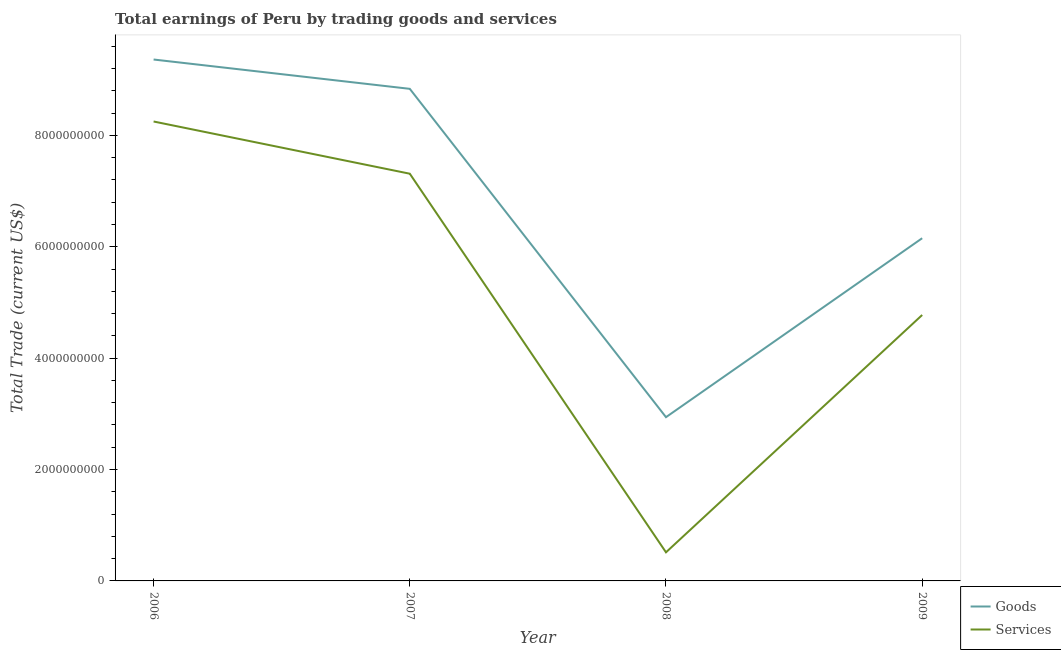How many different coloured lines are there?
Ensure brevity in your answer.  2. Is the number of lines equal to the number of legend labels?
Your answer should be very brief. Yes. What is the amount earned by trading goods in 2008?
Offer a very short reply. 2.94e+09. Across all years, what is the maximum amount earned by trading goods?
Offer a terse response. 9.36e+09. Across all years, what is the minimum amount earned by trading services?
Your answer should be compact. 5.14e+08. What is the total amount earned by trading services in the graph?
Keep it short and to the point. 2.08e+1. What is the difference between the amount earned by trading services in 2006 and that in 2007?
Keep it short and to the point. 9.37e+08. What is the difference between the amount earned by trading services in 2009 and the amount earned by trading goods in 2007?
Give a very brief answer. -4.06e+09. What is the average amount earned by trading goods per year?
Provide a succinct answer. 6.82e+09. In the year 2007, what is the difference between the amount earned by trading goods and amount earned by trading services?
Give a very brief answer. 1.52e+09. What is the ratio of the amount earned by trading goods in 2008 to that in 2009?
Offer a very short reply. 0.48. Is the difference between the amount earned by trading services in 2007 and 2009 greater than the difference between the amount earned by trading goods in 2007 and 2009?
Offer a very short reply. No. What is the difference between the highest and the second highest amount earned by trading services?
Your answer should be compact. 9.37e+08. What is the difference between the highest and the lowest amount earned by trading services?
Offer a very short reply. 7.74e+09. In how many years, is the amount earned by trading services greater than the average amount earned by trading services taken over all years?
Ensure brevity in your answer.  2. Is the sum of the amount earned by trading services in 2006 and 2007 greater than the maximum amount earned by trading goods across all years?
Keep it short and to the point. Yes. How many years are there in the graph?
Your answer should be compact. 4. What is the difference between two consecutive major ticks on the Y-axis?
Keep it short and to the point. 2.00e+09. Are the values on the major ticks of Y-axis written in scientific E-notation?
Provide a short and direct response. No. Does the graph contain grids?
Provide a short and direct response. No. What is the title of the graph?
Offer a terse response. Total earnings of Peru by trading goods and services. Does "Services" appear as one of the legend labels in the graph?
Ensure brevity in your answer.  Yes. What is the label or title of the Y-axis?
Make the answer very short. Total Trade (current US$). What is the Total Trade (current US$) of Goods in 2006?
Your answer should be compact. 9.36e+09. What is the Total Trade (current US$) in Services in 2006?
Your answer should be very brief. 8.25e+09. What is the Total Trade (current US$) of Goods in 2007?
Ensure brevity in your answer.  8.84e+09. What is the Total Trade (current US$) in Services in 2007?
Keep it short and to the point. 7.31e+09. What is the Total Trade (current US$) of Goods in 2008?
Make the answer very short. 2.94e+09. What is the Total Trade (current US$) in Services in 2008?
Keep it short and to the point. 5.14e+08. What is the Total Trade (current US$) in Goods in 2009?
Your answer should be compact. 6.15e+09. What is the Total Trade (current US$) of Services in 2009?
Ensure brevity in your answer.  4.77e+09. Across all years, what is the maximum Total Trade (current US$) of Goods?
Offer a very short reply. 9.36e+09. Across all years, what is the maximum Total Trade (current US$) in Services?
Give a very brief answer. 8.25e+09. Across all years, what is the minimum Total Trade (current US$) of Goods?
Your response must be concise. 2.94e+09. Across all years, what is the minimum Total Trade (current US$) of Services?
Give a very brief answer. 5.14e+08. What is the total Total Trade (current US$) in Goods in the graph?
Give a very brief answer. 2.73e+1. What is the total Total Trade (current US$) of Services in the graph?
Give a very brief answer. 2.08e+1. What is the difference between the Total Trade (current US$) of Goods in 2006 and that in 2007?
Your response must be concise. 5.26e+08. What is the difference between the Total Trade (current US$) of Services in 2006 and that in 2007?
Make the answer very short. 9.37e+08. What is the difference between the Total Trade (current US$) of Goods in 2006 and that in 2008?
Your answer should be compact. 6.42e+09. What is the difference between the Total Trade (current US$) in Services in 2006 and that in 2008?
Your answer should be very brief. 7.74e+09. What is the difference between the Total Trade (current US$) of Goods in 2006 and that in 2009?
Your answer should be very brief. 3.21e+09. What is the difference between the Total Trade (current US$) in Services in 2006 and that in 2009?
Your response must be concise. 3.47e+09. What is the difference between the Total Trade (current US$) of Goods in 2007 and that in 2008?
Your answer should be very brief. 5.90e+09. What is the difference between the Total Trade (current US$) in Services in 2007 and that in 2008?
Give a very brief answer. 6.80e+09. What is the difference between the Total Trade (current US$) of Goods in 2007 and that in 2009?
Provide a short and direct response. 2.68e+09. What is the difference between the Total Trade (current US$) of Services in 2007 and that in 2009?
Provide a short and direct response. 2.54e+09. What is the difference between the Total Trade (current US$) in Goods in 2008 and that in 2009?
Ensure brevity in your answer.  -3.21e+09. What is the difference between the Total Trade (current US$) of Services in 2008 and that in 2009?
Make the answer very short. -4.26e+09. What is the difference between the Total Trade (current US$) in Goods in 2006 and the Total Trade (current US$) in Services in 2007?
Your answer should be very brief. 2.05e+09. What is the difference between the Total Trade (current US$) of Goods in 2006 and the Total Trade (current US$) of Services in 2008?
Provide a succinct answer. 8.85e+09. What is the difference between the Total Trade (current US$) of Goods in 2006 and the Total Trade (current US$) of Services in 2009?
Offer a very short reply. 4.59e+09. What is the difference between the Total Trade (current US$) of Goods in 2007 and the Total Trade (current US$) of Services in 2008?
Your answer should be very brief. 8.32e+09. What is the difference between the Total Trade (current US$) of Goods in 2007 and the Total Trade (current US$) of Services in 2009?
Offer a very short reply. 4.06e+09. What is the difference between the Total Trade (current US$) of Goods in 2008 and the Total Trade (current US$) of Services in 2009?
Ensure brevity in your answer.  -1.83e+09. What is the average Total Trade (current US$) in Goods per year?
Provide a short and direct response. 6.82e+09. What is the average Total Trade (current US$) of Services per year?
Ensure brevity in your answer.  5.21e+09. In the year 2006, what is the difference between the Total Trade (current US$) of Goods and Total Trade (current US$) of Services?
Provide a short and direct response. 1.11e+09. In the year 2007, what is the difference between the Total Trade (current US$) in Goods and Total Trade (current US$) in Services?
Provide a short and direct response. 1.52e+09. In the year 2008, what is the difference between the Total Trade (current US$) in Goods and Total Trade (current US$) in Services?
Make the answer very short. 2.43e+09. In the year 2009, what is the difference between the Total Trade (current US$) of Goods and Total Trade (current US$) of Services?
Offer a terse response. 1.38e+09. What is the ratio of the Total Trade (current US$) of Goods in 2006 to that in 2007?
Provide a short and direct response. 1.06. What is the ratio of the Total Trade (current US$) in Services in 2006 to that in 2007?
Your answer should be compact. 1.13. What is the ratio of the Total Trade (current US$) in Goods in 2006 to that in 2008?
Offer a very short reply. 3.18. What is the ratio of the Total Trade (current US$) in Services in 2006 to that in 2008?
Your answer should be very brief. 16.06. What is the ratio of the Total Trade (current US$) of Goods in 2006 to that in 2009?
Provide a short and direct response. 1.52. What is the ratio of the Total Trade (current US$) in Services in 2006 to that in 2009?
Give a very brief answer. 1.73. What is the ratio of the Total Trade (current US$) of Goods in 2007 to that in 2008?
Give a very brief answer. 3. What is the ratio of the Total Trade (current US$) of Services in 2007 to that in 2008?
Offer a very short reply. 14.23. What is the ratio of the Total Trade (current US$) in Goods in 2007 to that in 2009?
Keep it short and to the point. 1.44. What is the ratio of the Total Trade (current US$) of Services in 2007 to that in 2009?
Your response must be concise. 1.53. What is the ratio of the Total Trade (current US$) of Goods in 2008 to that in 2009?
Make the answer very short. 0.48. What is the ratio of the Total Trade (current US$) in Services in 2008 to that in 2009?
Keep it short and to the point. 0.11. What is the difference between the highest and the second highest Total Trade (current US$) in Goods?
Keep it short and to the point. 5.26e+08. What is the difference between the highest and the second highest Total Trade (current US$) of Services?
Provide a succinct answer. 9.37e+08. What is the difference between the highest and the lowest Total Trade (current US$) of Goods?
Keep it short and to the point. 6.42e+09. What is the difference between the highest and the lowest Total Trade (current US$) in Services?
Give a very brief answer. 7.74e+09. 